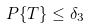<formula> <loc_0><loc_0><loc_500><loc_500>P \{ T \} \leq \delta _ { 3 }</formula> 